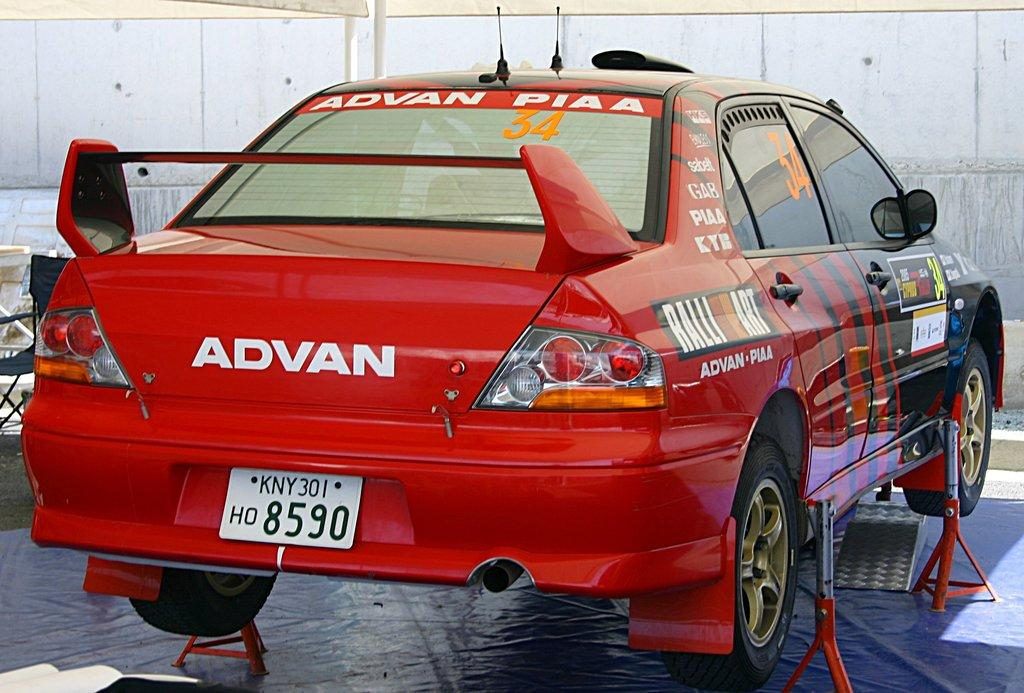What is the main subject of the image? There is a vehicle in the image. What else can be seen in the image besides the vehicle? There are other objects in the image. Can you describe the background of the image? There is a wall, poles, and a chair in the background of the image, along with other objects. What type of feather can be seen floating in the air in the image? There is no feather present in the image. What time of day is it in the image, considering the presence of the afternoon sun? The facts provided do not mention the time of day or the presence of the sun, so we cannot determine if it is afternoon or not. 